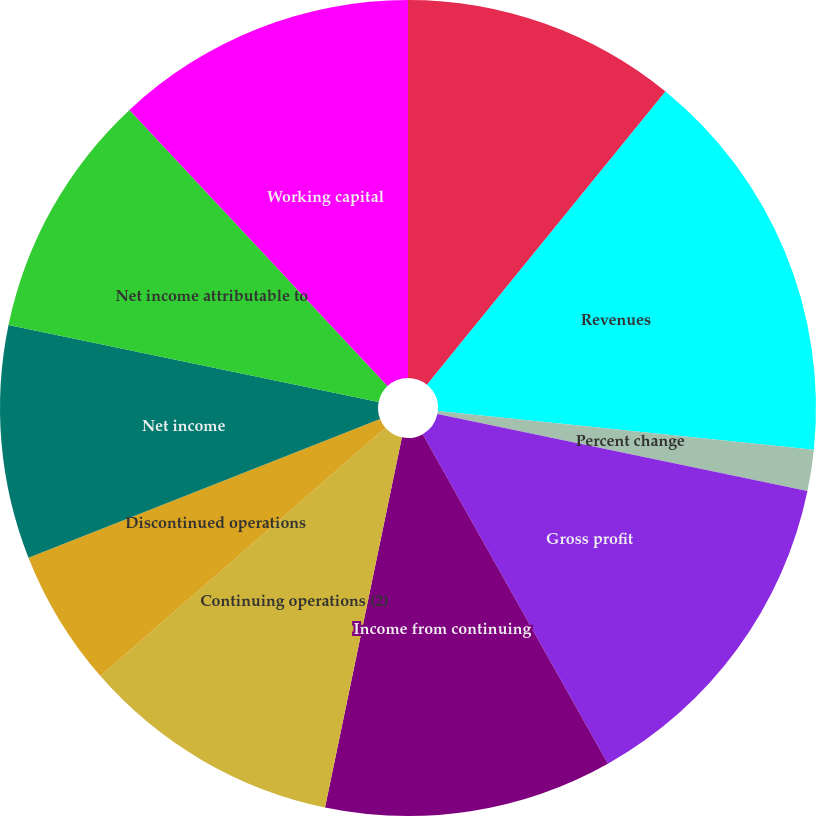<chart> <loc_0><loc_0><loc_500><loc_500><pie_chart><fcel>(In millions except per share<fcel>Revenues<fcel>Percent change<fcel>Gross profit<fcel>Income from continuing<fcel>Continuing operations (2)<fcel>Discontinued operations<fcel>Net income<fcel>Net income attributable to<fcel>Working capital<nl><fcel>10.87%<fcel>15.76%<fcel>1.63%<fcel>13.59%<fcel>11.41%<fcel>10.33%<fcel>5.43%<fcel>9.24%<fcel>9.78%<fcel>11.96%<nl></chart> 